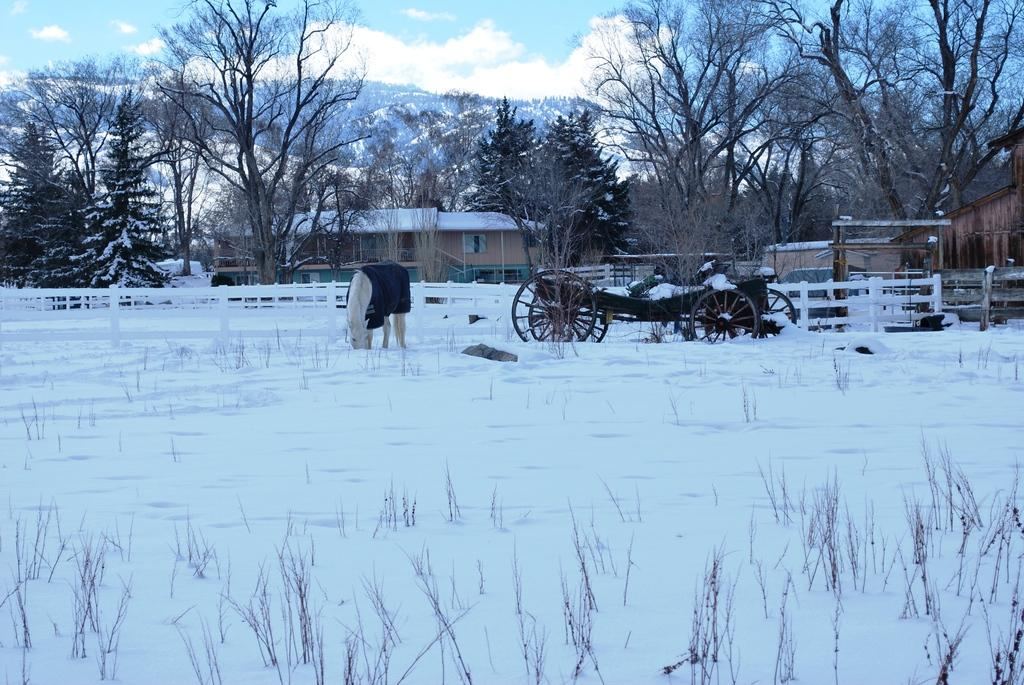What is the main object in the image? There is a cart in the image. What animal is associated with the cart? There is a horse in the image. What is the weather like in the image? There is snow in the image, indicating a cold and likely wintery environment. What type of vegetation can be seen in the image? There are plants in the image. What architectural features are visible in the background of the image? The background of the image includes fences, houses, wells, and hills. What is the condition of the sky in the image? The sky is cloudy in the background of the image. How many members are on the team playing in the image? There is no team or any indication of a game or sporting activity in the image. Can you tell me how many baths are visible in the image? There are no baths present in the image. 